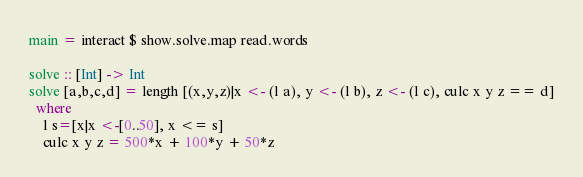Convert code to text. <code><loc_0><loc_0><loc_500><loc_500><_Haskell_>main = interact $ show.solve.map read.words

solve :: [Int] -> Int
solve [a,b,c,d] = length [(x,y,z)|x <- (l a), y <- (l b), z <- (l c), culc x y z == d]
  where
    l s=[x|x <-[0..50], x <= s] 
    culc x y z = 500*x + 100*y + 50*z</code> 